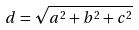Convert formula to latex. <formula><loc_0><loc_0><loc_500><loc_500>d = \sqrt { a ^ { 2 } + b ^ { 2 } + c ^ { 2 } }</formula> 